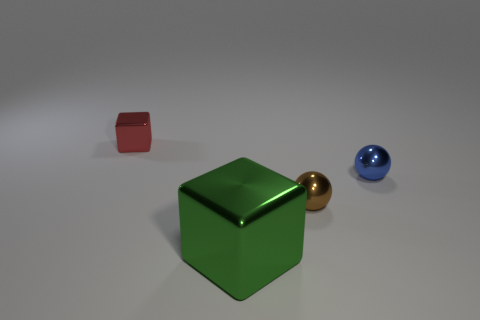Are there any other things that are the same size as the green object?
Keep it short and to the point. No. There is another object that is the same shape as the large green object; what is its color?
Your answer should be very brief. Red. Are there more small cubes behind the large green block than large cyan things?
Ensure brevity in your answer.  Yes. What number of other objects are the same size as the red thing?
Offer a terse response. 2. What number of blocks are both behind the brown metallic sphere and to the right of the tiny shiny cube?
Provide a short and direct response. 0. Is the ball behind the small brown sphere made of the same material as the big green cube?
Your response must be concise. Yes. There is a brown thing that is behind the block that is in front of the shiny cube behind the big metal thing; what shape is it?
Your answer should be very brief. Sphere. Are there the same number of brown metal objects on the left side of the brown metallic ball and small things in front of the green shiny thing?
Give a very brief answer. Yes. The other shiny ball that is the same size as the blue metal sphere is what color?
Keep it short and to the point. Brown. How many small objects are either brown objects or red things?
Offer a very short reply. 2. 